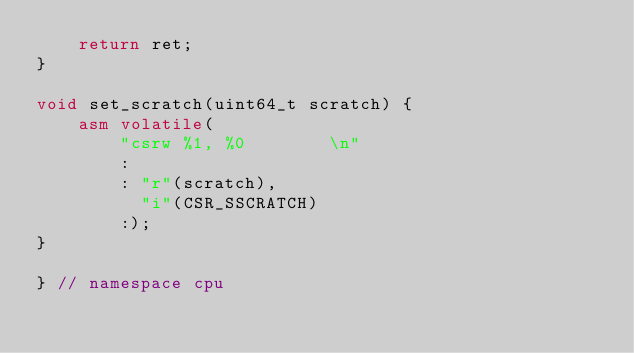<code> <loc_0><loc_0><loc_500><loc_500><_C++_>	return ret;
}

void set_scratch(uint64_t scratch) {
	asm volatile(
		"csrw %1, %0		\n"
		:
		: "r"(scratch),
		  "i"(CSR_SSCRATCH)
		:);
}

} // namespace cpu
</code> 